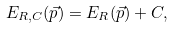<formula> <loc_0><loc_0><loc_500><loc_500>E _ { R , C } ( \vec { p } ) = E _ { R } ( \vec { p } ) + C ,</formula> 